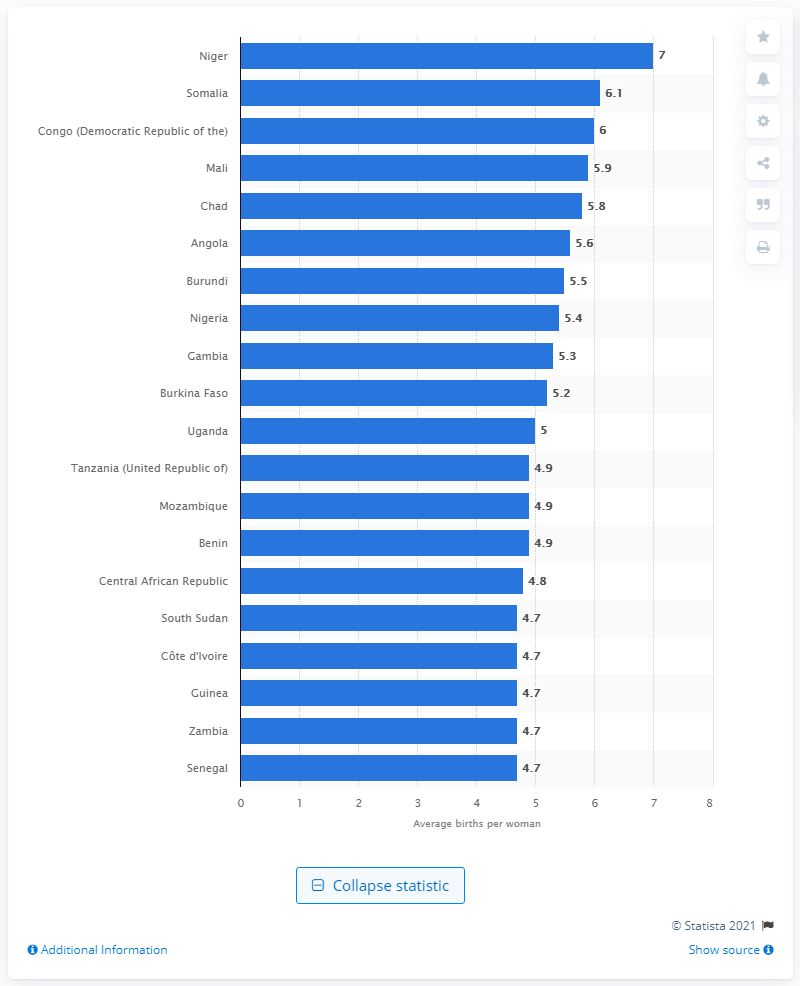What country had the highest average birth rate per woman in the world?
 Niger 